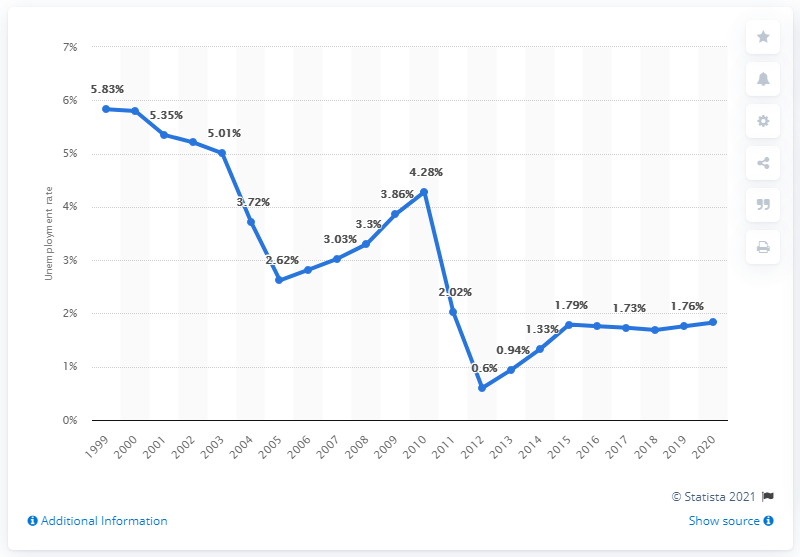Point out several critical features in this image. The unemployment rate in Madagascar was 1.83% in 2020. 